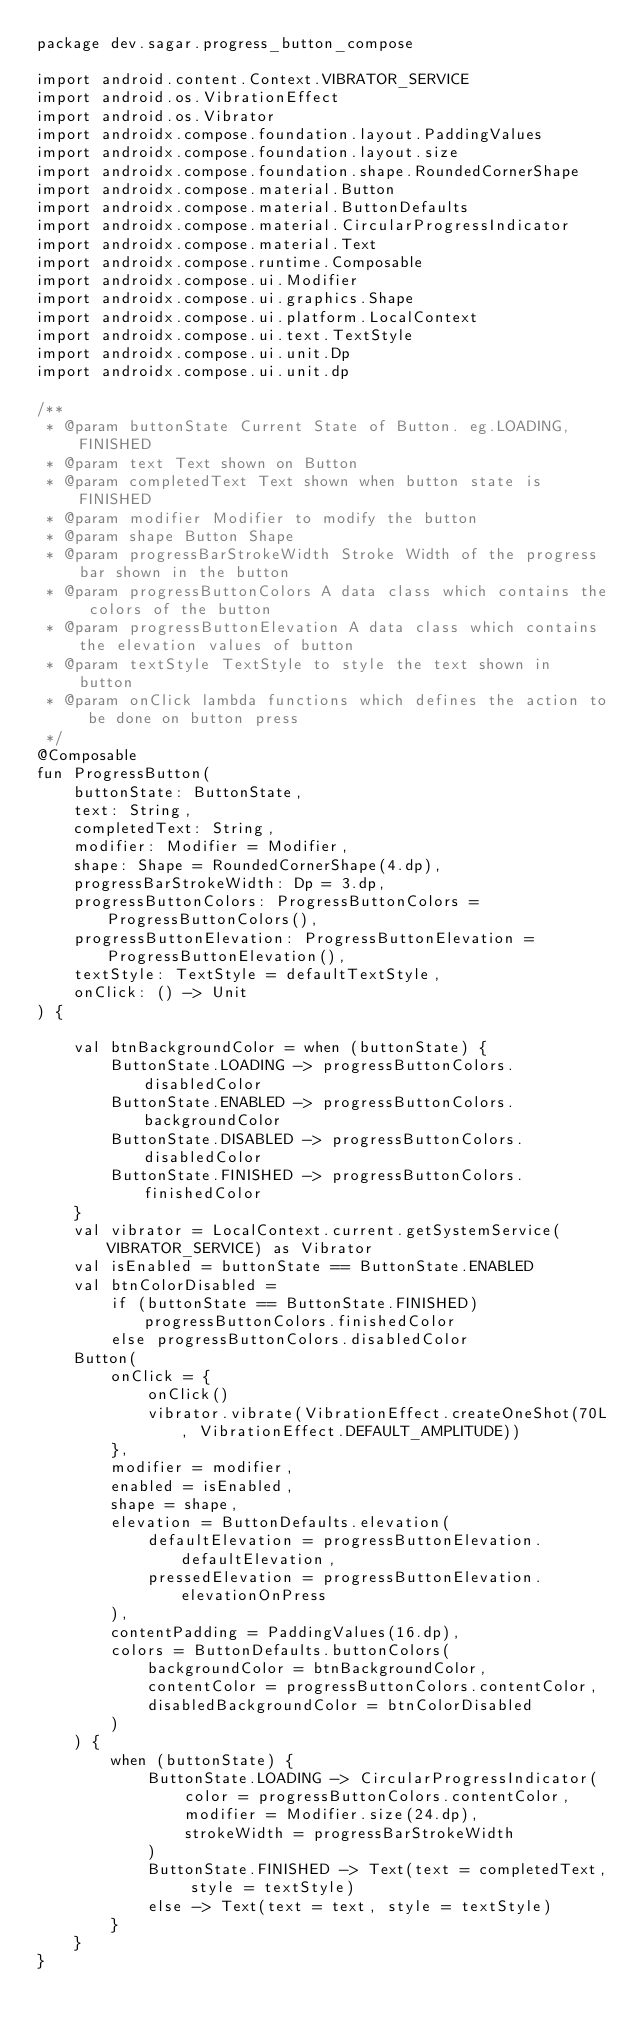Convert code to text. <code><loc_0><loc_0><loc_500><loc_500><_Kotlin_>package dev.sagar.progress_button_compose

import android.content.Context.VIBRATOR_SERVICE
import android.os.VibrationEffect
import android.os.Vibrator
import androidx.compose.foundation.layout.PaddingValues
import androidx.compose.foundation.layout.size
import androidx.compose.foundation.shape.RoundedCornerShape
import androidx.compose.material.Button
import androidx.compose.material.ButtonDefaults
import androidx.compose.material.CircularProgressIndicator
import androidx.compose.material.Text
import androidx.compose.runtime.Composable
import androidx.compose.ui.Modifier
import androidx.compose.ui.graphics.Shape
import androidx.compose.ui.platform.LocalContext
import androidx.compose.ui.text.TextStyle
import androidx.compose.ui.unit.Dp
import androidx.compose.ui.unit.dp

/**
 * @param buttonState Current State of Button. eg.LOADING, FINISHED
 * @param text Text shown on Button
 * @param completedText Text shown when button state is FINISHED
 * @param modifier Modifier to modify the button
 * @param shape Button Shape
 * @param progressBarStrokeWidth Stroke Width of the progress bar shown in the button
 * @param progressButtonColors A data class which contains the colors of the button
 * @param progressButtonElevation A data class which contains the elevation values of button
 * @param textStyle TextStyle to style the text shown in button
 * @param onClick lambda functions which defines the action to be done on button press
 */
@Composable
fun ProgressButton(
    buttonState: ButtonState,
    text: String,
    completedText: String,
    modifier: Modifier = Modifier,
    shape: Shape = RoundedCornerShape(4.dp),
    progressBarStrokeWidth: Dp = 3.dp,
    progressButtonColors: ProgressButtonColors = ProgressButtonColors(),
    progressButtonElevation: ProgressButtonElevation = ProgressButtonElevation(),
    textStyle: TextStyle = defaultTextStyle,
    onClick: () -> Unit
) {

    val btnBackgroundColor = when (buttonState) {
        ButtonState.LOADING -> progressButtonColors.disabledColor
        ButtonState.ENABLED -> progressButtonColors.backgroundColor
        ButtonState.DISABLED -> progressButtonColors.disabledColor
        ButtonState.FINISHED -> progressButtonColors.finishedColor
    }
    val vibrator = LocalContext.current.getSystemService(VIBRATOR_SERVICE) as Vibrator
    val isEnabled = buttonState == ButtonState.ENABLED
    val btnColorDisabled =
        if (buttonState == ButtonState.FINISHED) progressButtonColors.finishedColor
        else progressButtonColors.disabledColor
    Button(
        onClick = {
            onClick()
            vibrator.vibrate(VibrationEffect.createOneShot(70L, VibrationEffect.DEFAULT_AMPLITUDE))
        },
        modifier = modifier,
        enabled = isEnabled,
        shape = shape,
        elevation = ButtonDefaults.elevation(
            defaultElevation = progressButtonElevation.defaultElevation,
            pressedElevation = progressButtonElevation.elevationOnPress
        ),
        contentPadding = PaddingValues(16.dp),
        colors = ButtonDefaults.buttonColors(
            backgroundColor = btnBackgroundColor,
            contentColor = progressButtonColors.contentColor,
            disabledBackgroundColor = btnColorDisabled
        )
    ) {
        when (buttonState) {
            ButtonState.LOADING -> CircularProgressIndicator(
                color = progressButtonColors.contentColor,
                modifier = Modifier.size(24.dp),
                strokeWidth = progressBarStrokeWidth
            )
            ButtonState.FINISHED -> Text(text = completedText, style = textStyle)
            else -> Text(text = text, style = textStyle)
        }
    }
}
</code> 